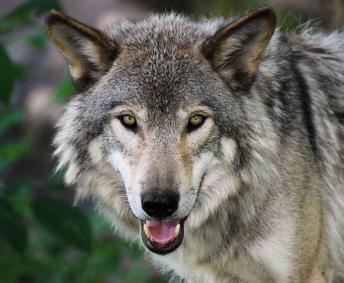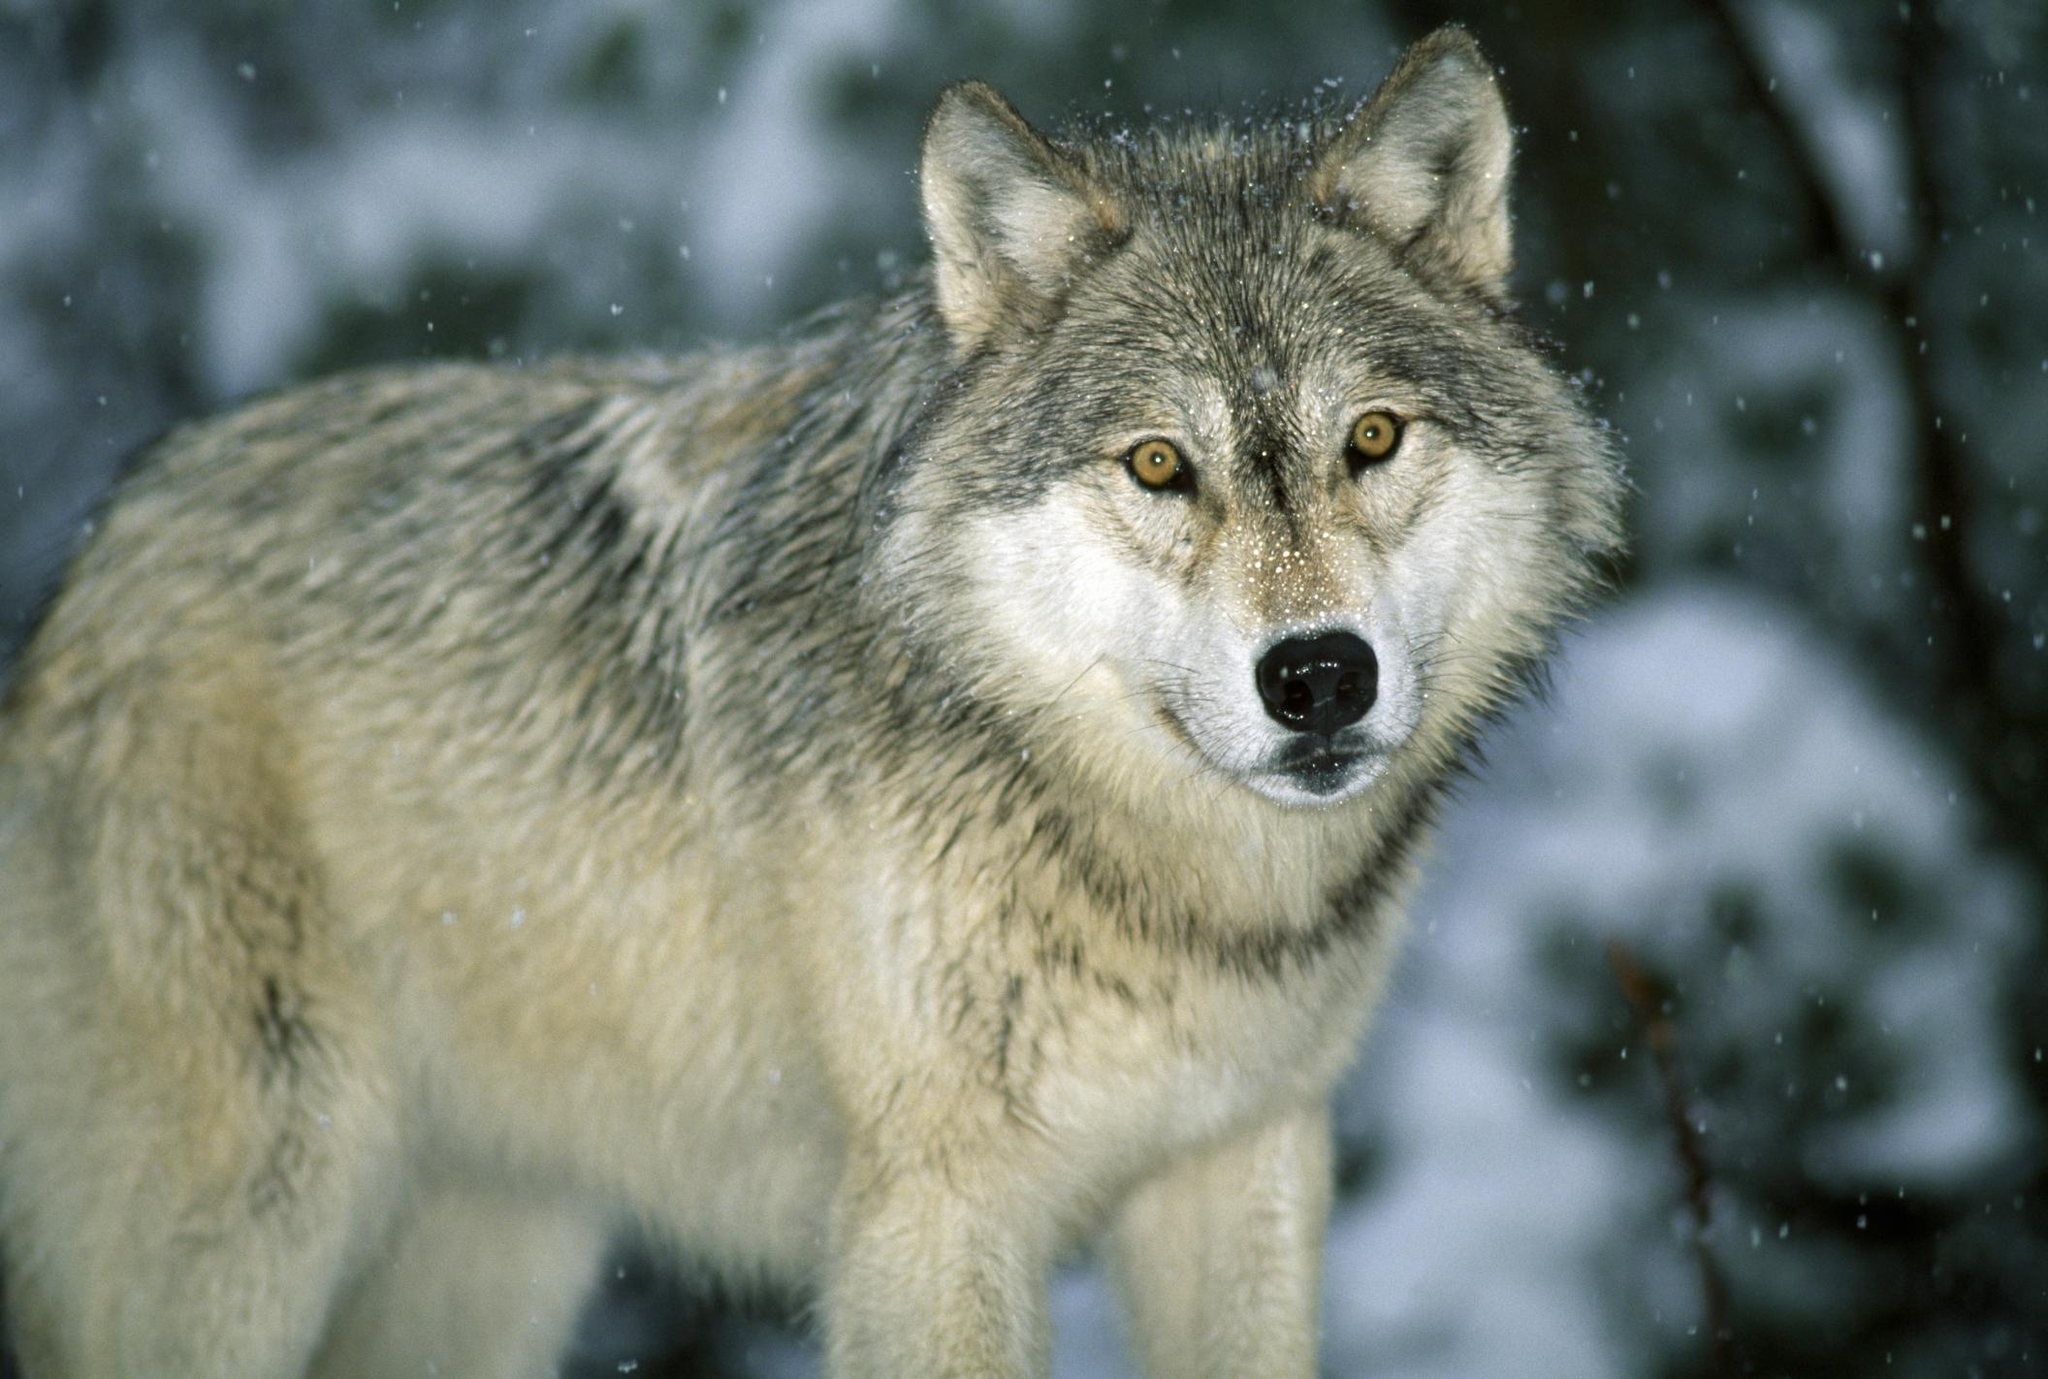The first image is the image on the left, the second image is the image on the right. Given the left and right images, does the statement "The wolf in the left image is looking left." hold true? Answer yes or no. No. The first image is the image on the left, the second image is the image on the right. For the images shown, is this caption "The wolf in the image on the left is in front of red foliage." true? Answer yes or no. No. 